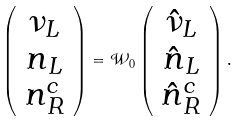Convert formula to latex. <formula><loc_0><loc_0><loc_500><loc_500>\left ( \begin{array} { c } \nu _ { L } \\ n _ { L } \\ n ^ { c } _ { R } \end{array} \right ) = \mathcal { W } _ { 0 } \left ( \begin{array} { c } \hat { \nu } _ { L } \\ \hat { n } _ { L } \\ \hat { n } ^ { c } _ { R } \end{array} \right ) .</formula> 